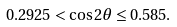<formula> <loc_0><loc_0><loc_500><loc_500>0 . 2 9 2 5 < \cos 2 \theta \leq 0 . 5 8 5 .</formula> 